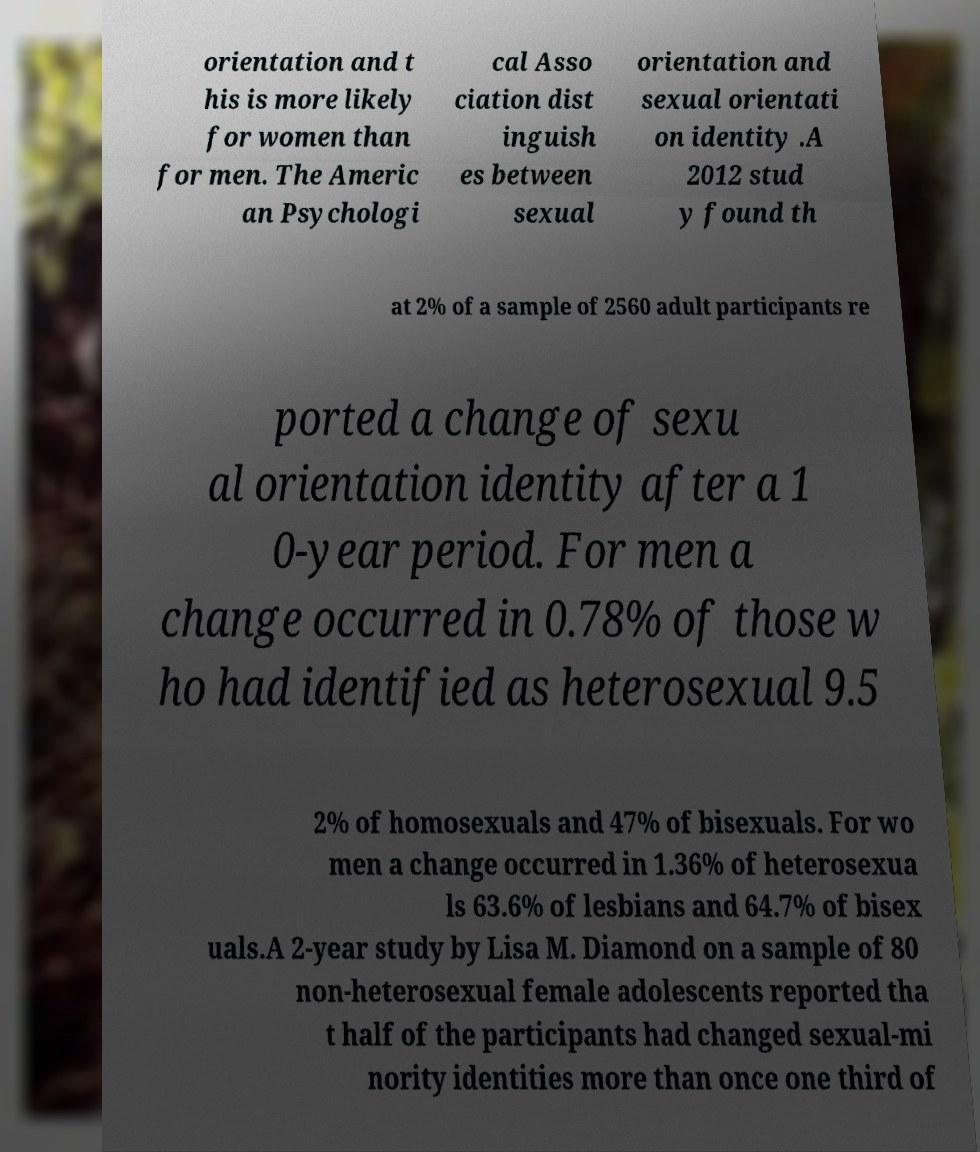Can you read and provide the text displayed in the image?This photo seems to have some interesting text. Can you extract and type it out for me? orientation and t his is more likely for women than for men. The Americ an Psychologi cal Asso ciation dist inguish es between sexual orientation and sexual orientati on identity .A 2012 stud y found th at 2% of a sample of 2560 adult participants re ported a change of sexu al orientation identity after a 1 0-year period. For men a change occurred in 0.78% of those w ho had identified as heterosexual 9.5 2% of homosexuals and 47% of bisexuals. For wo men a change occurred in 1.36% of heterosexua ls 63.6% of lesbians and 64.7% of bisex uals.A 2-year study by Lisa M. Diamond on a sample of 80 non-heterosexual female adolescents reported tha t half of the participants had changed sexual-mi nority identities more than once one third of 